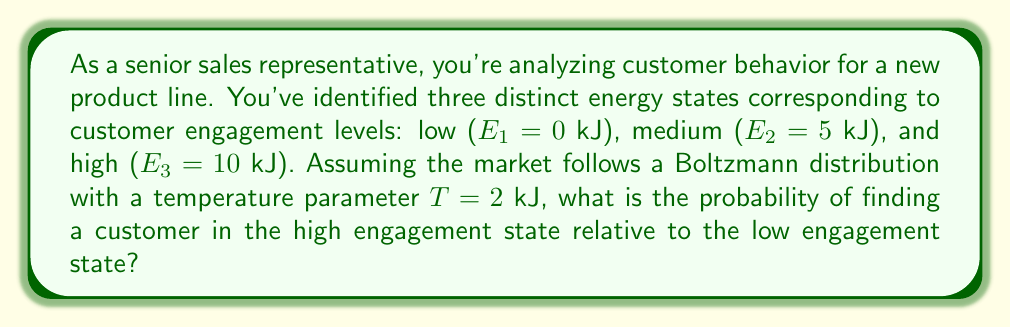Could you help me with this problem? To solve this problem, we'll use the Boltzmann distribution formula and compare the probabilities of the high and low energy states.

1) The Boltzmann distribution gives the probability of a system being in a state with energy $E_i$ as:

   $$P(E_i) \propto e^{-E_i/kT}$$

   where $k$ is Boltzmann's constant and $T$ is the temperature.

2) We're interested in the ratio of probabilities, so we can ignore the proportionality constant:

   $$\frac{P(E_3)}{P(E_1)} = \frac{e^{-E_3/kT}}{e^{-E_1/kT}}$$

3) Substitute the given values:
   $E_3 = 10$ kJ, $E_1 = 0$ kJ, $T = 2$ kJ

   $$\frac{P(E_3)}{P(E_1)} = \frac{e^{-10/2}}{e^{-0/2}} = e^{-5}$$

4) Calculate the exponential:

   $$e^{-5} \approx 0.00674$$

Therefore, the probability of finding a customer in the high engagement state is approximately 0.00674 times the probability of finding a customer in the low engagement state.
Answer: $e^{-5} \approx 0.00674$ 